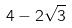Convert formula to latex. <formula><loc_0><loc_0><loc_500><loc_500>4 - 2 \sqrt { 3 }</formula> 